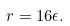Convert formula to latex. <formula><loc_0><loc_0><loc_500><loc_500>r = 1 6 \epsilon .</formula> 